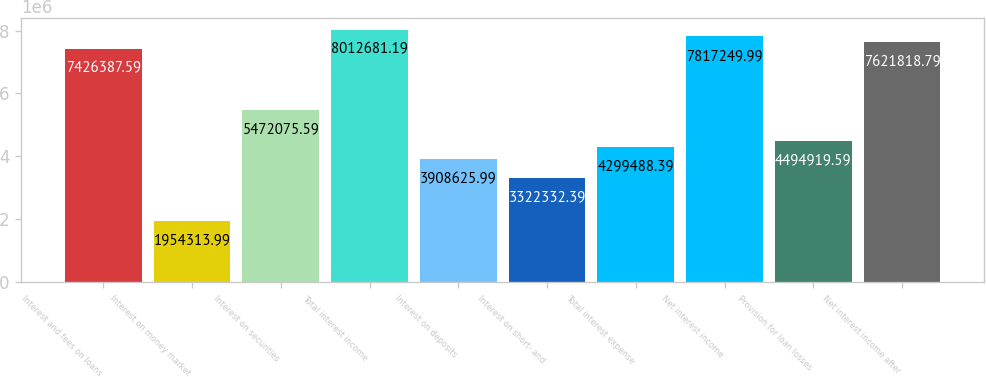Convert chart. <chart><loc_0><loc_0><loc_500><loc_500><bar_chart><fcel>Interest and fees on loans<fcel>Interest on money market<fcel>Interest on securities<fcel>Total interest income<fcel>Interest on deposits<fcel>Interest on short- and<fcel>Total interest expense<fcel>Net interest income<fcel>Provision for loan losses<fcel>Net interest income after<nl><fcel>7.42639e+06<fcel>1.95431e+06<fcel>5.47208e+06<fcel>8.01268e+06<fcel>3.90863e+06<fcel>3.32233e+06<fcel>4.29949e+06<fcel>7.81725e+06<fcel>4.49492e+06<fcel>7.62182e+06<nl></chart> 